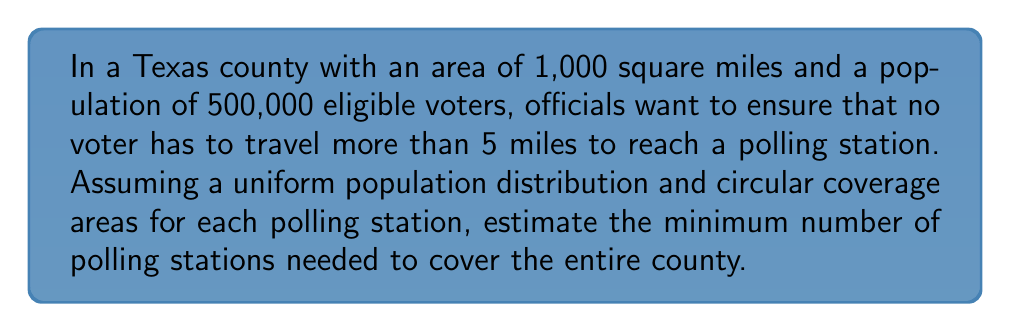Teach me how to tackle this problem. Let's approach this step-by-step:

1) Each polling station covers a circular area with a radius of 5 miles.

2) The area covered by each polling station is:
   $$A = \pi r^2 = \pi (5^2) = 25\pi \approx 78.54 \text{ square miles}$$

3) The total area of the county is 1,000 square miles.

4) To find the number of polling stations, we divide the total area by the area covered by each station:
   $$N = \frac{\text{Total Area}}{\text{Area per Station}} = \frac{1000}{25\pi} \approx 12.73$$

5) However, circular coverage areas will overlap and leave gaps, so we need to adjust for this inefficiency. A common rule of thumb is to multiply by 1.5:
   $$N_{\text{adjusted}} = 12.73 \times 1.5 \approx 19.10$$

6) Rounding up to ensure full coverage, we need at least 20 polling stations.

7) To verify if this is sufficient for the population:
   $$\text{Voters per station} = \frac{500,000}{20} = 25,000$$

This is a reasonable number of voters per station for a single day of voting. However, if early voting is implemented (common in Texas), this number would be more manageable over several days.
Answer: 20 polling stations 